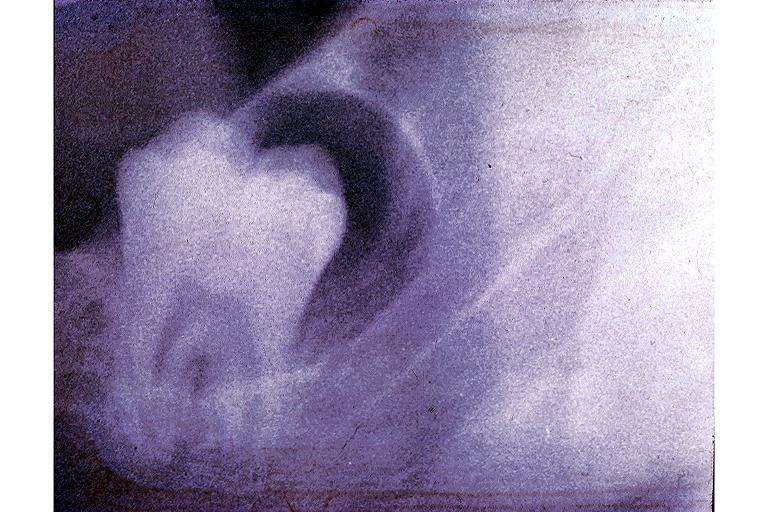what does this image show?
Answer the question using a single word or phrase. Dentigerous cyst 